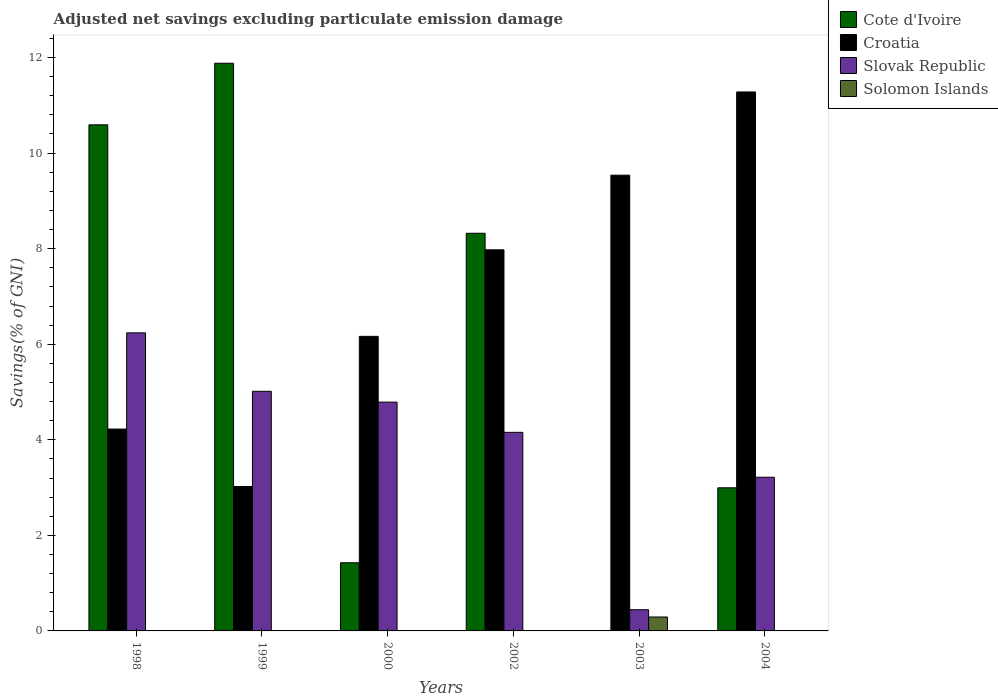How many different coloured bars are there?
Ensure brevity in your answer.  4. Are the number of bars per tick equal to the number of legend labels?
Offer a terse response. No. Are the number of bars on each tick of the X-axis equal?
Provide a short and direct response. Yes. What is the adjusted net savings in Solomon Islands in 2002?
Your response must be concise. 0. Across all years, what is the maximum adjusted net savings in Slovak Republic?
Offer a very short reply. 6.24. Across all years, what is the minimum adjusted net savings in Solomon Islands?
Give a very brief answer. 0. What is the total adjusted net savings in Slovak Republic in the graph?
Give a very brief answer. 23.86. What is the difference between the adjusted net savings in Croatia in 2003 and that in 2004?
Your answer should be compact. -1.74. What is the difference between the adjusted net savings in Slovak Republic in 2002 and the adjusted net savings in Solomon Islands in 2004?
Provide a succinct answer. 4.16. What is the average adjusted net savings in Slovak Republic per year?
Keep it short and to the point. 3.98. In the year 2003, what is the difference between the adjusted net savings in Solomon Islands and adjusted net savings in Slovak Republic?
Make the answer very short. -0.15. What is the ratio of the adjusted net savings in Slovak Republic in 1999 to that in 2003?
Give a very brief answer. 11.3. Is the adjusted net savings in Cote d'Ivoire in 1999 less than that in 2004?
Your answer should be compact. No. What is the difference between the highest and the second highest adjusted net savings in Slovak Republic?
Offer a terse response. 1.22. What is the difference between the highest and the lowest adjusted net savings in Croatia?
Provide a succinct answer. 8.26. In how many years, is the adjusted net savings in Slovak Republic greater than the average adjusted net savings in Slovak Republic taken over all years?
Make the answer very short. 4. Is it the case that in every year, the sum of the adjusted net savings in Croatia and adjusted net savings in Cote d'Ivoire is greater than the adjusted net savings in Solomon Islands?
Offer a terse response. Yes. How many bars are there?
Give a very brief answer. 18. What is the difference between two consecutive major ticks on the Y-axis?
Give a very brief answer. 2. Are the values on the major ticks of Y-axis written in scientific E-notation?
Keep it short and to the point. No. How many legend labels are there?
Provide a succinct answer. 4. How are the legend labels stacked?
Provide a succinct answer. Vertical. What is the title of the graph?
Your answer should be compact. Adjusted net savings excluding particulate emission damage. Does "Kiribati" appear as one of the legend labels in the graph?
Offer a terse response. No. What is the label or title of the X-axis?
Your answer should be very brief. Years. What is the label or title of the Y-axis?
Ensure brevity in your answer.  Savings(% of GNI). What is the Savings(% of GNI) in Cote d'Ivoire in 1998?
Ensure brevity in your answer.  10.59. What is the Savings(% of GNI) in Croatia in 1998?
Provide a short and direct response. 4.22. What is the Savings(% of GNI) in Slovak Republic in 1998?
Your answer should be compact. 6.24. What is the Savings(% of GNI) in Solomon Islands in 1998?
Make the answer very short. 0. What is the Savings(% of GNI) of Cote d'Ivoire in 1999?
Your answer should be very brief. 11.88. What is the Savings(% of GNI) of Croatia in 1999?
Provide a short and direct response. 3.02. What is the Savings(% of GNI) of Slovak Republic in 1999?
Give a very brief answer. 5.02. What is the Savings(% of GNI) in Solomon Islands in 1999?
Provide a short and direct response. 0. What is the Savings(% of GNI) of Cote d'Ivoire in 2000?
Your answer should be very brief. 1.43. What is the Savings(% of GNI) of Croatia in 2000?
Offer a terse response. 6.16. What is the Savings(% of GNI) in Slovak Republic in 2000?
Make the answer very short. 4.79. What is the Savings(% of GNI) in Cote d'Ivoire in 2002?
Provide a succinct answer. 8.32. What is the Savings(% of GNI) of Croatia in 2002?
Ensure brevity in your answer.  7.98. What is the Savings(% of GNI) of Slovak Republic in 2002?
Your response must be concise. 4.16. What is the Savings(% of GNI) of Croatia in 2003?
Ensure brevity in your answer.  9.54. What is the Savings(% of GNI) of Slovak Republic in 2003?
Give a very brief answer. 0.44. What is the Savings(% of GNI) in Solomon Islands in 2003?
Keep it short and to the point. 0.29. What is the Savings(% of GNI) in Cote d'Ivoire in 2004?
Keep it short and to the point. 3. What is the Savings(% of GNI) in Croatia in 2004?
Offer a very short reply. 11.28. What is the Savings(% of GNI) in Slovak Republic in 2004?
Provide a succinct answer. 3.22. Across all years, what is the maximum Savings(% of GNI) in Cote d'Ivoire?
Make the answer very short. 11.88. Across all years, what is the maximum Savings(% of GNI) of Croatia?
Provide a short and direct response. 11.28. Across all years, what is the maximum Savings(% of GNI) in Slovak Republic?
Keep it short and to the point. 6.24. Across all years, what is the maximum Savings(% of GNI) in Solomon Islands?
Keep it short and to the point. 0.29. Across all years, what is the minimum Savings(% of GNI) in Croatia?
Ensure brevity in your answer.  3.02. Across all years, what is the minimum Savings(% of GNI) in Slovak Republic?
Give a very brief answer. 0.44. What is the total Savings(% of GNI) of Cote d'Ivoire in the graph?
Your answer should be very brief. 35.22. What is the total Savings(% of GNI) in Croatia in the graph?
Your response must be concise. 42.21. What is the total Savings(% of GNI) of Slovak Republic in the graph?
Make the answer very short. 23.86. What is the total Savings(% of GNI) of Solomon Islands in the graph?
Provide a short and direct response. 0.29. What is the difference between the Savings(% of GNI) in Cote d'Ivoire in 1998 and that in 1999?
Offer a very short reply. -1.29. What is the difference between the Savings(% of GNI) of Croatia in 1998 and that in 1999?
Your response must be concise. 1.2. What is the difference between the Savings(% of GNI) in Slovak Republic in 1998 and that in 1999?
Provide a succinct answer. 1.22. What is the difference between the Savings(% of GNI) of Cote d'Ivoire in 1998 and that in 2000?
Offer a very short reply. 9.17. What is the difference between the Savings(% of GNI) of Croatia in 1998 and that in 2000?
Make the answer very short. -1.94. What is the difference between the Savings(% of GNI) of Slovak Republic in 1998 and that in 2000?
Give a very brief answer. 1.45. What is the difference between the Savings(% of GNI) of Cote d'Ivoire in 1998 and that in 2002?
Give a very brief answer. 2.27. What is the difference between the Savings(% of GNI) of Croatia in 1998 and that in 2002?
Your response must be concise. -3.75. What is the difference between the Savings(% of GNI) of Slovak Republic in 1998 and that in 2002?
Keep it short and to the point. 2.08. What is the difference between the Savings(% of GNI) in Croatia in 1998 and that in 2003?
Keep it short and to the point. -5.31. What is the difference between the Savings(% of GNI) of Slovak Republic in 1998 and that in 2003?
Provide a succinct answer. 5.79. What is the difference between the Savings(% of GNI) of Cote d'Ivoire in 1998 and that in 2004?
Offer a very short reply. 7.6. What is the difference between the Savings(% of GNI) of Croatia in 1998 and that in 2004?
Give a very brief answer. -7.06. What is the difference between the Savings(% of GNI) of Slovak Republic in 1998 and that in 2004?
Your answer should be very brief. 3.02. What is the difference between the Savings(% of GNI) in Cote d'Ivoire in 1999 and that in 2000?
Provide a succinct answer. 10.45. What is the difference between the Savings(% of GNI) in Croatia in 1999 and that in 2000?
Provide a succinct answer. -3.14. What is the difference between the Savings(% of GNI) of Slovak Republic in 1999 and that in 2000?
Ensure brevity in your answer.  0.23. What is the difference between the Savings(% of GNI) of Cote d'Ivoire in 1999 and that in 2002?
Offer a terse response. 3.56. What is the difference between the Savings(% of GNI) of Croatia in 1999 and that in 2002?
Your response must be concise. -4.95. What is the difference between the Savings(% of GNI) of Slovak Republic in 1999 and that in 2002?
Provide a succinct answer. 0.86. What is the difference between the Savings(% of GNI) of Croatia in 1999 and that in 2003?
Your answer should be very brief. -6.52. What is the difference between the Savings(% of GNI) in Slovak Republic in 1999 and that in 2003?
Your answer should be compact. 4.57. What is the difference between the Savings(% of GNI) of Cote d'Ivoire in 1999 and that in 2004?
Your answer should be compact. 8.89. What is the difference between the Savings(% of GNI) in Croatia in 1999 and that in 2004?
Your answer should be very brief. -8.26. What is the difference between the Savings(% of GNI) of Slovak Republic in 1999 and that in 2004?
Your answer should be very brief. 1.8. What is the difference between the Savings(% of GNI) of Cote d'Ivoire in 2000 and that in 2002?
Offer a terse response. -6.9. What is the difference between the Savings(% of GNI) in Croatia in 2000 and that in 2002?
Give a very brief answer. -1.81. What is the difference between the Savings(% of GNI) of Slovak Republic in 2000 and that in 2002?
Keep it short and to the point. 0.63. What is the difference between the Savings(% of GNI) in Croatia in 2000 and that in 2003?
Keep it short and to the point. -3.37. What is the difference between the Savings(% of GNI) in Slovak Republic in 2000 and that in 2003?
Keep it short and to the point. 4.34. What is the difference between the Savings(% of GNI) in Cote d'Ivoire in 2000 and that in 2004?
Your answer should be compact. -1.57. What is the difference between the Savings(% of GNI) of Croatia in 2000 and that in 2004?
Offer a terse response. -5.12. What is the difference between the Savings(% of GNI) of Slovak Republic in 2000 and that in 2004?
Your answer should be very brief. 1.57. What is the difference between the Savings(% of GNI) of Croatia in 2002 and that in 2003?
Your answer should be very brief. -1.56. What is the difference between the Savings(% of GNI) in Slovak Republic in 2002 and that in 2003?
Provide a succinct answer. 3.71. What is the difference between the Savings(% of GNI) of Cote d'Ivoire in 2002 and that in 2004?
Provide a succinct answer. 5.33. What is the difference between the Savings(% of GNI) in Croatia in 2002 and that in 2004?
Offer a very short reply. -3.3. What is the difference between the Savings(% of GNI) of Slovak Republic in 2002 and that in 2004?
Offer a very short reply. 0.94. What is the difference between the Savings(% of GNI) in Croatia in 2003 and that in 2004?
Your answer should be compact. -1.74. What is the difference between the Savings(% of GNI) in Slovak Republic in 2003 and that in 2004?
Provide a succinct answer. -2.77. What is the difference between the Savings(% of GNI) in Cote d'Ivoire in 1998 and the Savings(% of GNI) in Croatia in 1999?
Offer a terse response. 7.57. What is the difference between the Savings(% of GNI) in Cote d'Ivoire in 1998 and the Savings(% of GNI) in Slovak Republic in 1999?
Offer a very short reply. 5.58. What is the difference between the Savings(% of GNI) in Croatia in 1998 and the Savings(% of GNI) in Slovak Republic in 1999?
Make the answer very short. -0.79. What is the difference between the Savings(% of GNI) in Cote d'Ivoire in 1998 and the Savings(% of GNI) in Croatia in 2000?
Offer a very short reply. 4.43. What is the difference between the Savings(% of GNI) of Cote d'Ivoire in 1998 and the Savings(% of GNI) of Slovak Republic in 2000?
Your answer should be compact. 5.8. What is the difference between the Savings(% of GNI) in Croatia in 1998 and the Savings(% of GNI) in Slovak Republic in 2000?
Provide a short and direct response. -0.56. What is the difference between the Savings(% of GNI) of Cote d'Ivoire in 1998 and the Savings(% of GNI) of Croatia in 2002?
Your answer should be compact. 2.62. What is the difference between the Savings(% of GNI) in Cote d'Ivoire in 1998 and the Savings(% of GNI) in Slovak Republic in 2002?
Make the answer very short. 6.44. What is the difference between the Savings(% of GNI) in Croatia in 1998 and the Savings(% of GNI) in Slovak Republic in 2002?
Provide a short and direct response. 0.07. What is the difference between the Savings(% of GNI) of Cote d'Ivoire in 1998 and the Savings(% of GNI) of Croatia in 2003?
Make the answer very short. 1.05. What is the difference between the Savings(% of GNI) in Cote d'Ivoire in 1998 and the Savings(% of GNI) in Slovak Republic in 2003?
Offer a very short reply. 10.15. What is the difference between the Savings(% of GNI) in Cote d'Ivoire in 1998 and the Savings(% of GNI) in Solomon Islands in 2003?
Give a very brief answer. 10.3. What is the difference between the Savings(% of GNI) of Croatia in 1998 and the Savings(% of GNI) of Slovak Republic in 2003?
Give a very brief answer. 3.78. What is the difference between the Savings(% of GNI) in Croatia in 1998 and the Savings(% of GNI) in Solomon Islands in 2003?
Make the answer very short. 3.93. What is the difference between the Savings(% of GNI) in Slovak Republic in 1998 and the Savings(% of GNI) in Solomon Islands in 2003?
Provide a short and direct response. 5.95. What is the difference between the Savings(% of GNI) of Cote d'Ivoire in 1998 and the Savings(% of GNI) of Croatia in 2004?
Provide a succinct answer. -0.69. What is the difference between the Savings(% of GNI) in Cote d'Ivoire in 1998 and the Savings(% of GNI) in Slovak Republic in 2004?
Your answer should be compact. 7.38. What is the difference between the Savings(% of GNI) of Cote d'Ivoire in 1999 and the Savings(% of GNI) of Croatia in 2000?
Offer a terse response. 5.72. What is the difference between the Savings(% of GNI) of Cote d'Ivoire in 1999 and the Savings(% of GNI) of Slovak Republic in 2000?
Ensure brevity in your answer.  7.09. What is the difference between the Savings(% of GNI) of Croatia in 1999 and the Savings(% of GNI) of Slovak Republic in 2000?
Provide a short and direct response. -1.77. What is the difference between the Savings(% of GNI) of Cote d'Ivoire in 1999 and the Savings(% of GNI) of Croatia in 2002?
Provide a short and direct response. 3.9. What is the difference between the Savings(% of GNI) in Cote d'Ivoire in 1999 and the Savings(% of GNI) in Slovak Republic in 2002?
Your answer should be very brief. 7.72. What is the difference between the Savings(% of GNI) in Croatia in 1999 and the Savings(% of GNI) in Slovak Republic in 2002?
Ensure brevity in your answer.  -1.13. What is the difference between the Savings(% of GNI) in Cote d'Ivoire in 1999 and the Savings(% of GNI) in Croatia in 2003?
Your answer should be very brief. 2.34. What is the difference between the Savings(% of GNI) of Cote d'Ivoire in 1999 and the Savings(% of GNI) of Slovak Republic in 2003?
Offer a very short reply. 11.44. What is the difference between the Savings(% of GNI) in Cote d'Ivoire in 1999 and the Savings(% of GNI) in Solomon Islands in 2003?
Keep it short and to the point. 11.59. What is the difference between the Savings(% of GNI) in Croatia in 1999 and the Savings(% of GNI) in Slovak Republic in 2003?
Your answer should be very brief. 2.58. What is the difference between the Savings(% of GNI) in Croatia in 1999 and the Savings(% of GNI) in Solomon Islands in 2003?
Ensure brevity in your answer.  2.73. What is the difference between the Savings(% of GNI) of Slovak Republic in 1999 and the Savings(% of GNI) of Solomon Islands in 2003?
Offer a terse response. 4.72. What is the difference between the Savings(% of GNI) in Cote d'Ivoire in 1999 and the Savings(% of GNI) in Croatia in 2004?
Ensure brevity in your answer.  0.6. What is the difference between the Savings(% of GNI) of Cote d'Ivoire in 1999 and the Savings(% of GNI) of Slovak Republic in 2004?
Make the answer very short. 8.66. What is the difference between the Savings(% of GNI) in Croatia in 1999 and the Savings(% of GNI) in Slovak Republic in 2004?
Offer a very short reply. -0.19. What is the difference between the Savings(% of GNI) in Cote d'Ivoire in 2000 and the Savings(% of GNI) in Croatia in 2002?
Offer a very short reply. -6.55. What is the difference between the Savings(% of GNI) of Cote d'Ivoire in 2000 and the Savings(% of GNI) of Slovak Republic in 2002?
Offer a very short reply. -2.73. What is the difference between the Savings(% of GNI) in Croatia in 2000 and the Savings(% of GNI) in Slovak Republic in 2002?
Your answer should be compact. 2.01. What is the difference between the Savings(% of GNI) of Cote d'Ivoire in 2000 and the Savings(% of GNI) of Croatia in 2003?
Provide a succinct answer. -8.11. What is the difference between the Savings(% of GNI) of Cote d'Ivoire in 2000 and the Savings(% of GNI) of Solomon Islands in 2003?
Your response must be concise. 1.14. What is the difference between the Savings(% of GNI) in Croatia in 2000 and the Savings(% of GNI) in Slovak Republic in 2003?
Ensure brevity in your answer.  5.72. What is the difference between the Savings(% of GNI) of Croatia in 2000 and the Savings(% of GNI) of Solomon Islands in 2003?
Your answer should be very brief. 5.87. What is the difference between the Savings(% of GNI) in Slovak Republic in 2000 and the Savings(% of GNI) in Solomon Islands in 2003?
Keep it short and to the point. 4.5. What is the difference between the Savings(% of GNI) in Cote d'Ivoire in 2000 and the Savings(% of GNI) in Croatia in 2004?
Give a very brief answer. -9.85. What is the difference between the Savings(% of GNI) of Cote d'Ivoire in 2000 and the Savings(% of GNI) of Slovak Republic in 2004?
Your answer should be very brief. -1.79. What is the difference between the Savings(% of GNI) in Croatia in 2000 and the Savings(% of GNI) in Slovak Republic in 2004?
Provide a short and direct response. 2.95. What is the difference between the Savings(% of GNI) in Cote d'Ivoire in 2002 and the Savings(% of GNI) in Croatia in 2003?
Offer a terse response. -1.22. What is the difference between the Savings(% of GNI) of Cote d'Ivoire in 2002 and the Savings(% of GNI) of Slovak Republic in 2003?
Make the answer very short. 7.88. What is the difference between the Savings(% of GNI) of Cote d'Ivoire in 2002 and the Savings(% of GNI) of Solomon Islands in 2003?
Your answer should be compact. 8.03. What is the difference between the Savings(% of GNI) of Croatia in 2002 and the Savings(% of GNI) of Slovak Republic in 2003?
Give a very brief answer. 7.53. What is the difference between the Savings(% of GNI) of Croatia in 2002 and the Savings(% of GNI) of Solomon Islands in 2003?
Offer a terse response. 7.68. What is the difference between the Savings(% of GNI) in Slovak Republic in 2002 and the Savings(% of GNI) in Solomon Islands in 2003?
Your answer should be very brief. 3.86. What is the difference between the Savings(% of GNI) of Cote d'Ivoire in 2002 and the Savings(% of GNI) of Croatia in 2004?
Keep it short and to the point. -2.96. What is the difference between the Savings(% of GNI) in Cote d'Ivoire in 2002 and the Savings(% of GNI) in Slovak Republic in 2004?
Offer a terse response. 5.11. What is the difference between the Savings(% of GNI) in Croatia in 2002 and the Savings(% of GNI) in Slovak Republic in 2004?
Your response must be concise. 4.76. What is the difference between the Savings(% of GNI) in Croatia in 2003 and the Savings(% of GNI) in Slovak Republic in 2004?
Keep it short and to the point. 6.32. What is the average Savings(% of GNI) in Cote d'Ivoire per year?
Keep it short and to the point. 5.87. What is the average Savings(% of GNI) in Croatia per year?
Offer a terse response. 7.03. What is the average Savings(% of GNI) in Slovak Republic per year?
Offer a terse response. 3.98. What is the average Savings(% of GNI) in Solomon Islands per year?
Provide a short and direct response. 0.05. In the year 1998, what is the difference between the Savings(% of GNI) in Cote d'Ivoire and Savings(% of GNI) in Croatia?
Your answer should be compact. 6.37. In the year 1998, what is the difference between the Savings(% of GNI) in Cote d'Ivoire and Savings(% of GNI) in Slovak Republic?
Your answer should be very brief. 4.35. In the year 1998, what is the difference between the Savings(% of GNI) of Croatia and Savings(% of GNI) of Slovak Republic?
Ensure brevity in your answer.  -2.01. In the year 1999, what is the difference between the Savings(% of GNI) of Cote d'Ivoire and Savings(% of GNI) of Croatia?
Your answer should be very brief. 8.86. In the year 1999, what is the difference between the Savings(% of GNI) of Cote d'Ivoire and Savings(% of GNI) of Slovak Republic?
Your answer should be compact. 6.87. In the year 1999, what is the difference between the Savings(% of GNI) of Croatia and Savings(% of GNI) of Slovak Republic?
Keep it short and to the point. -1.99. In the year 2000, what is the difference between the Savings(% of GNI) of Cote d'Ivoire and Savings(% of GNI) of Croatia?
Your response must be concise. -4.74. In the year 2000, what is the difference between the Savings(% of GNI) in Cote d'Ivoire and Savings(% of GNI) in Slovak Republic?
Ensure brevity in your answer.  -3.36. In the year 2000, what is the difference between the Savings(% of GNI) of Croatia and Savings(% of GNI) of Slovak Republic?
Make the answer very short. 1.38. In the year 2002, what is the difference between the Savings(% of GNI) in Cote d'Ivoire and Savings(% of GNI) in Croatia?
Offer a very short reply. 0.35. In the year 2002, what is the difference between the Savings(% of GNI) of Cote d'Ivoire and Savings(% of GNI) of Slovak Republic?
Give a very brief answer. 4.17. In the year 2002, what is the difference between the Savings(% of GNI) in Croatia and Savings(% of GNI) in Slovak Republic?
Make the answer very short. 3.82. In the year 2003, what is the difference between the Savings(% of GNI) in Croatia and Savings(% of GNI) in Slovak Republic?
Offer a very short reply. 9.09. In the year 2003, what is the difference between the Savings(% of GNI) of Croatia and Savings(% of GNI) of Solomon Islands?
Provide a short and direct response. 9.25. In the year 2003, what is the difference between the Savings(% of GNI) in Slovak Republic and Savings(% of GNI) in Solomon Islands?
Offer a terse response. 0.15. In the year 2004, what is the difference between the Savings(% of GNI) of Cote d'Ivoire and Savings(% of GNI) of Croatia?
Make the answer very short. -8.29. In the year 2004, what is the difference between the Savings(% of GNI) in Cote d'Ivoire and Savings(% of GNI) in Slovak Republic?
Offer a terse response. -0.22. In the year 2004, what is the difference between the Savings(% of GNI) in Croatia and Savings(% of GNI) in Slovak Republic?
Provide a succinct answer. 8.06. What is the ratio of the Savings(% of GNI) of Cote d'Ivoire in 1998 to that in 1999?
Make the answer very short. 0.89. What is the ratio of the Savings(% of GNI) of Croatia in 1998 to that in 1999?
Your answer should be very brief. 1.4. What is the ratio of the Savings(% of GNI) in Slovak Republic in 1998 to that in 1999?
Give a very brief answer. 1.24. What is the ratio of the Savings(% of GNI) of Cote d'Ivoire in 1998 to that in 2000?
Provide a succinct answer. 7.42. What is the ratio of the Savings(% of GNI) of Croatia in 1998 to that in 2000?
Ensure brevity in your answer.  0.69. What is the ratio of the Savings(% of GNI) of Slovak Republic in 1998 to that in 2000?
Provide a succinct answer. 1.3. What is the ratio of the Savings(% of GNI) of Cote d'Ivoire in 1998 to that in 2002?
Your answer should be very brief. 1.27. What is the ratio of the Savings(% of GNI) in Croatia in 1998 to that in 2002?
Offer a very short reply. 0.53. What is the ratio of the Savings(% of GNI) of Slovak Republic in 1998 to that in 2002?
Ensure brevity in your answer.  1.5. What is the ratio of the Savings(% of GNI) of Croatia in 1998 to that in 2003?
Your answer should be compact. 0.44. What is the ratio of the Savings(% of GNI) in Slovak Republic in 1998 to that in 2003?
Your answer should be very brief. 14.05. What is the ratio of the Savings(% of GNI) in Cote d'Ivoire in 1998 to that in 2004?
Offer a terse response. 3.54. What is the ratio of the Savings(% of GNI) in Croatia in 1998 to that in 2004?
Offer a very short reply. 0.37. What is the ratio of the Savings(% of GNI) in Slovak Republic in 1998 to that in 2004?
Make the answer very short. 1.94. What is the ratio of the Savings(% of GNI) of Cote d'Ivoire in 1999 to that in 2000?
Make the answer very short. 8.33. What is the ratio of the Savings(% of GNI) of Croatia in 1999 to that in 2000?
Your response must be concise. 0.49. What is the ratio of the Savings(% of GNI) in Slovak Republic in 1999 to that in 2000?
Provide a short and direct response. 1.05. What is the ratio of the Savings(% of GNI) of Cote d'Ivoire in 1999 to that in 2002?
Provide a succinct answer. 1.43. What is the ratio of the Savings(% of GNI) in Croatia in 1999 to that in 2002?
Ensure brevity in your answer.  0.38. What is the ratio of the Savings(% of GNI) in Slovak Republic in 1999 to that in 2002?
Your answer should be compact. 1.21. What is the ratio of the Savings(% of GNI) in Croatia in 1999 to that in 2003?
Give a very brief answer. 0.32. What is the ratio of the Savings(% of GNI) of Slovak Republic in 1999 to that in 2003?
Provide a succinct answer. 11.3. What is the ratio of the Savings(% of GNI) in Cote d'Ivoire in 1999 to that in 2004?
Your response must be concise. 3.97. What is the ratio of the Savings(% of GNI) of Croatia in 1999 to that in 2004?
Your answer should be very brief. 0.27. What is the ratio of the Savings(% of GNI) of Slovak Republic in 1999 to that in 2004?
Ensure brevity in your answer.  1.56. What is the ratio of the Savings(% of GNI) in Cote d'Ivoire in 2000 to that in 2002?
Offer a terse response. 0.17. What is the ratio of the Savings(% of GNI) in Croatia in 2000 to that in 2002?
Your answer should be compact. 0.77. What is the ratio of the Savings(% of GNI) in Slovak Republic in 2000 to that in 2002?
Give a very brief answer. 1.15. What is the ratio of the Savings(% of GNI) of Croatia in 2000 to that in 2003?
Offer a terse response. 0.65. What is the ratio of the Savings(% of GNI) of Slovak Republic in 2000 to that in 2003?
Offer a terse response. 10.78. What is the ratio of the Savings(% of GNI) in Cote d'Ivoire in 2000 to that in 2004?
Offer a very short reply. 0.48. What is the ratio of the Savings(% of GNI) in Croatia in 2000 to that in 2004?
Your answer should be very brief. 0.55. What is the ratio of the Savings(% of GNI) of Slovak Republic in 2000 to that in 2004?
Offer a terse response. 1.49. What is the ratio of the Savings(% of GNI) in Croatia in 2002 to that in 2003?
Your response must be concise. 0.84. What is the ratio of the Savings(% of GNI) of Slovak Republic in 2002 to that in 2003?
Make the answer very short. 9.36. What is the ratio of the Savings(% of GNI) in Cote d'Ivoire in 2002 to that in 2004?
Provide a short and direct response. 2.78. What is the ratio of the Savings(% of GNI) in Croatia in 2002 to that in 2004?
Provide a succinct answer. 0.71. What is the ratio of the Savings(% of GNI) in Slovak Republic in 2002 to that in 2004?
Provide a short and direct response. 1.29. What is the ratio of the Savings(% of GNI) in Croatia in 2003 to that in 2004?
Provide a succinct answer. 0.85. What is the ratio of the Savings(% of GNI) of Slovak Republic in 2003 to that in 2004?
Your answer should be very brief. 0.14. What is the difference between the highest and the second highest Savings(% of GNI) of Cote d'Ivoire?
Your response must be concise. 1.29. What is the difference between the highest and the second highest Savings(% of GNI) in Croatia?
Provide a short and direct response. 1.74. What is the difference between the highest and the second highest Savings(% of GNI) of Slovak Republic?
Provide a short and direct response. 1.22. What is the difference between the highest and the lowest Savings(% of GNI) in Cote d'Ivoire?
Provide a succinct answer. 11.88. What is the difference between the highest and the lowest Savings(% of GNI) of Croatia?
Provide a succinct answer. 8.26. What is the difference between the highest and the lowest Savings(% of GNI) in Slovak Republic?
Offer a very short reply. 5.79. What is the difference between the highest and the lowest Savings(% of GNI) in Solomon Islands?
Provide a succinct answer. 0.29. 